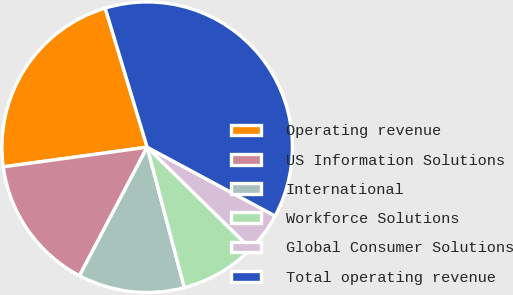Convert chart to OTSL. <chart><loc_0><loc_0><loc_500><loc_500><pie_chart><fcel>Operating revenue<fcel>US Information Solutions<fcel>International<fcel>Workforce Solutions<fcel>Global Consumer Solutions<fcel>Total operating revenue<nl><fcel>22.5%<fcel>15.13%<fcel>11.83%<fcel>8.53%<fcel>4.5%<fcel>37.51%<nl></chart> 